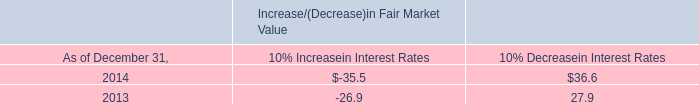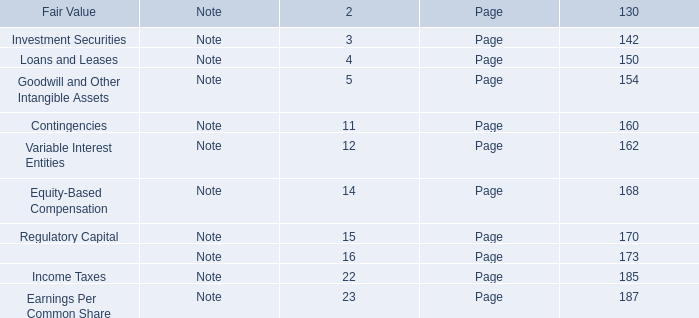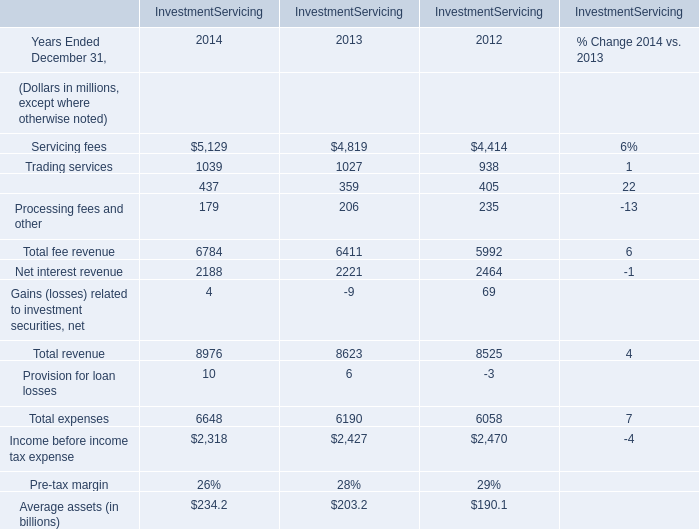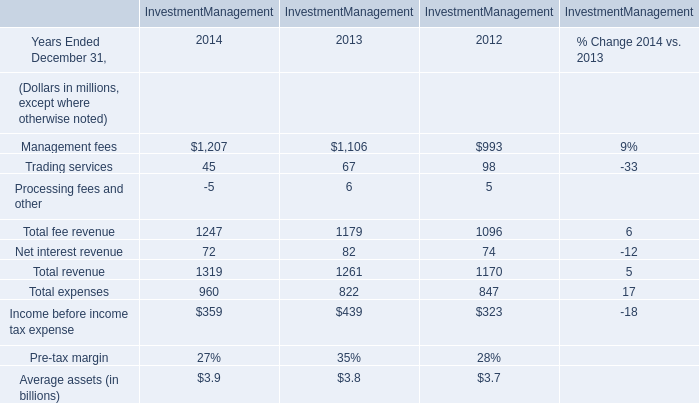If Total fee revenue for Investment Management develops with the same increasing rate as in 2013 Ended December 31, what will it reach in 2014 Ended December 31? (in million) 
Computations: (1179 * (1 + ((1179 - 1096) / 1096)))
Answer: 1268.28558. 